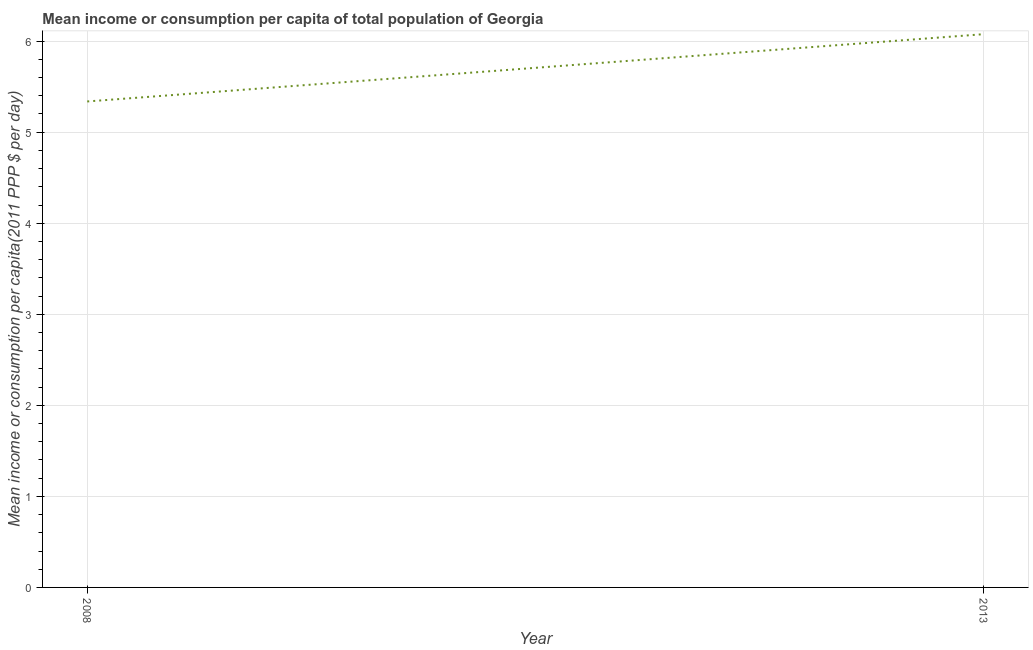What is the mean income or consumption in 2008?
Your response must be concise. 5.34. Across all years, what is the maximum mean income or consumption?
Make the answer very short. 6.08. Across all years, what is the minimum mean income or consumption?
Your answer should be very brief. 5.34. What is the sum of the mean income or consumption?
Offer a very short reply. 11.41. What is the difference between the mean income or consumption in 2008 and 2013?
Make the answer very short. -0.74. What is the average mean income or consumption per year?
Ensure brevity in your answer.  5.71. What is the median mean income or consumption?
Ensure brevity in your answer.  5.71. What is the ratio of the mean income or consumption in 2008 to that in 2013?
Your answer should be very brief. 0.88. Does the mean income or consumption monotonically increase over the years?
Keep it short and to the point. Yes. How many years are there in the graph?
Offer a terse response. 2. Are the values on the major ticks of Y-axis written in scientific E-notation?
Your answer should be compact. No. Does the graph contain grids?
Offer a very short reply. Yes. What is the title of the graph?
Offer a very short reply. Mean income or consumption per capita of total population of Georgia. What is the label or title of the X-axis?
Offer a very short reply. Year. What is the label or title of the Y-axis?
Offer a very short reply. Mean income or consumption per capita(2011 PPP $ per day). What is the Mean income or consumption per capita(2011 PPP $ per day) in 2008?
Your response must be concise. 5.34. What is the Mean income or consumption per capita(2011 PPP $ per day) in 2013?
Offer a very short reply. 6.08. What is the difference between the Mean income or consumption per capita(2011 PPP $ per day) in 2008 and 2013?
Provide a succinct answer. -0.74. What is the ratio of the Mean income or consumption per capita(2011 PPP $ per day) in 2008 to that in 2013?
Offer a very short reply. 0.88. 